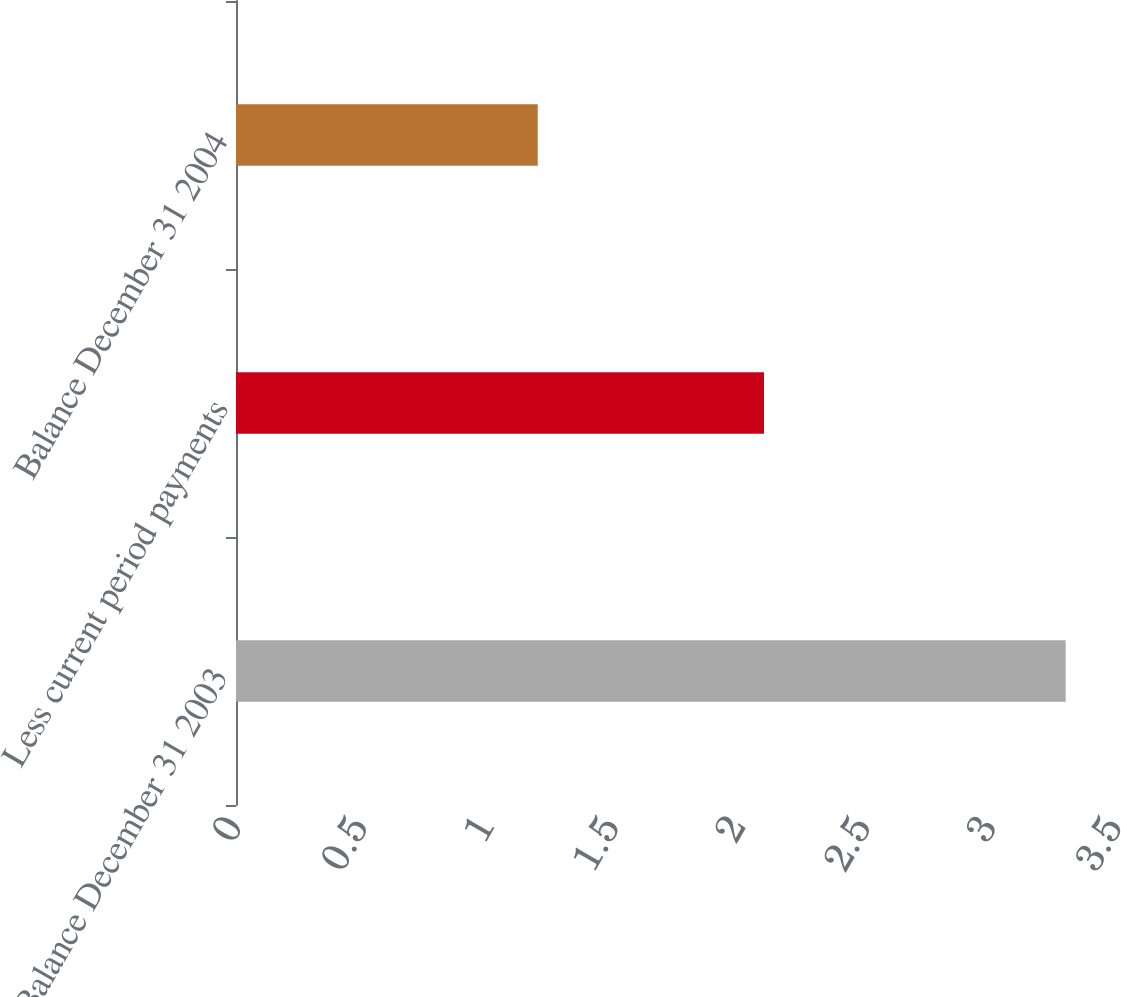<chart> <loc_0><loc_0><loc_500><loc_500><bar_chart><fcel>Balance December 31 2003<fcel>Less current period payments<fcel>Balance December 31 2004<nl><fcel>3.3<fcel>2.1<fcel>1.2<nl></chart> 